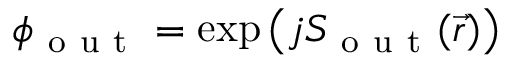Convert formula to latex. <formula><loc_0><loc_0><loc_500><loc_500>\phi _ { o u t } = \exp { \left ( j S _ { o u t } ( \vec { r } ) \right ) }</formula> 